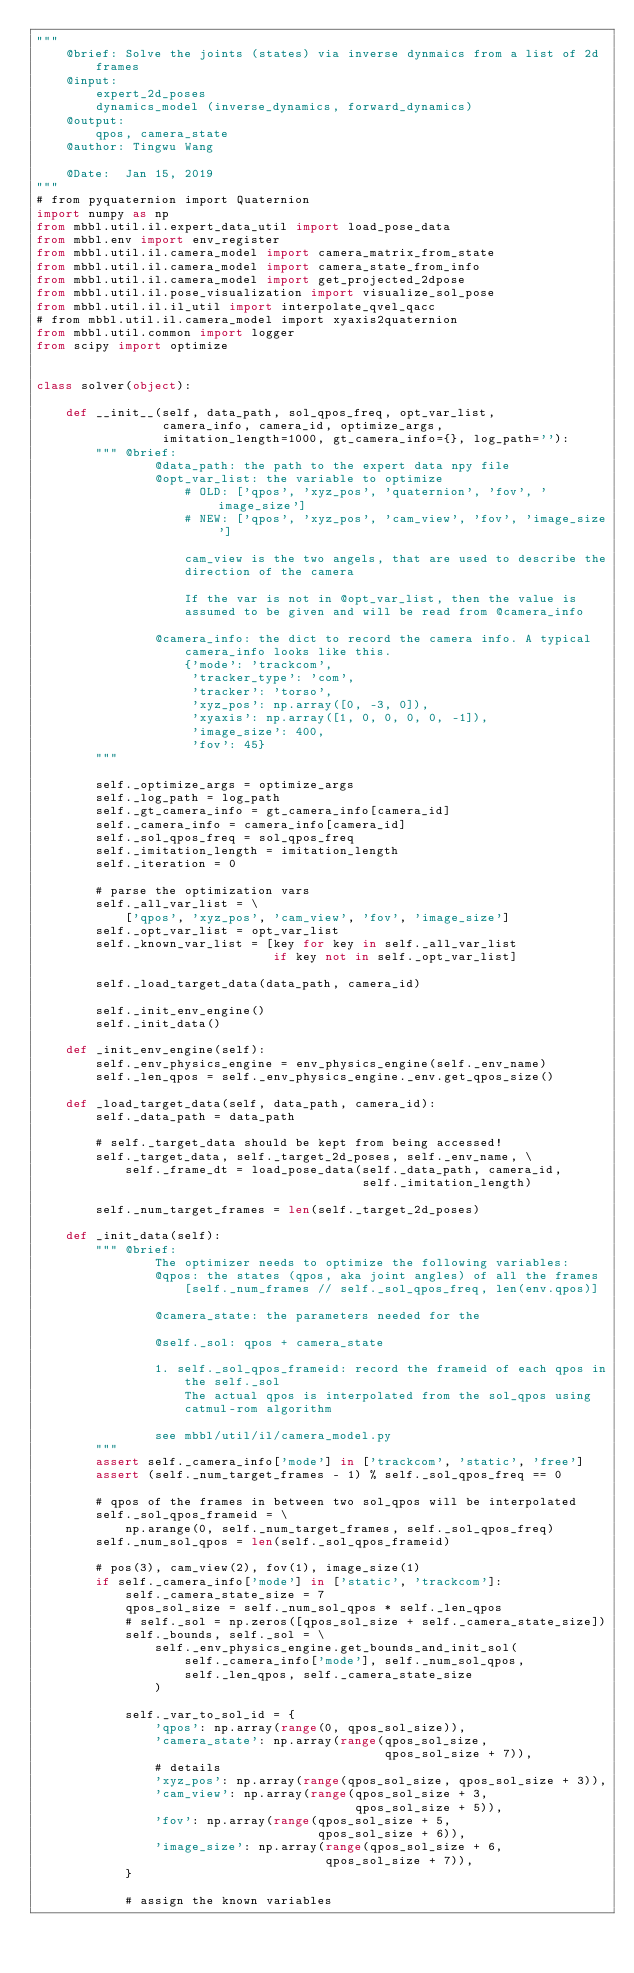<code> <loc_0><loc_0><loc_500><loc_500><_Python_>"""
    @brief: Solve the joints (states) via inverse dynmaics from a list of 2d
        frames
    @input:
        expert_2d_poses
        dynamics_model (inverse_dynamics, forward_dynamics)
    @output:
        qpos, camera_state
    @author: Tingwu Wang

    @Date:  Jan 15, 2019
"""
# from pyquaternion import Quaternion
import numpy as np
from mbbl.util.il.expert_data_util import load_pose_data
from mbbl.env import env_register
from mbbl.util.il.camera_model import camera_matrix_from_state
from mbbl.util.il.camera_model import camera_state_from_info
from mbbl.util.il.camera_model import get_projected_2dpose
from mbbl.util.il.pose_visualization import visualize_sol_pose
from mbbl.util.il.il_util import interpolate_qvel_qacc
# from mbbl.util.il.camera_model import xyaxis2quaternion
from mbbl.util.common import logger
from scipy import optimize


class solver(object):

    def __init__(self, data_path, sol_qpos_freq, opt_var_list,
                 camera_info, camera_id, optimize_args,
                 imitation_length=1000, gt_camera_info={}, log_path=''):
        """ @brief:
                @data_path: the path to the expert data npy file
                @opt_var_list: the variable to optimize
                    # OLD: ['qpos', 'xyz_pos', 'quaternion', 'fov', 'image_size']
                    # NEW: ['qpos', 'xyz_pos', 'cam_view', 'fov', 'image_size']

                    cam_view is the two angels, that are used to describe the
                    direction of the camera

                    If the var is not in @opt_var_list, then the value is
                    assumed to be given and will be read from @camera_info

                @camera_info: the dict to record the camera info. A typical
                    camera_info looks like this.
                    {'mode': 'trackcom',
                     'tracker_type': 'com',
                     'tracker': 'torso',
                     'xyz_pos': np.array([0, -3, 0]),
                     'xyaxis': np.array([1, 0, 0, 0, 0, -1]),
                     'image_size': 400,
                     'fov': 45}
        """

        self._optimize_args = optimize_args
        self._log_path = log_path
        self._gt_camera_info = gt_camera_info[camera_id]
        self._camera_info = camera_info[camera_id]
        self._sol_qpos_freq = sol_qpos_freq
        self._imitation_length = imitation_length
        self._iteration = 0

        # parse the optimization vars
        self._all_var_list = \
            ['qpos', 'xyz_pos', 'cam_view', 'fov', 'image_size']
        self._opt_var_list = opt_var_list
        self._known_var_list = [key for key in self._all_var_list
                                if key not in self._opt_var_list]

        self._load_target_data(data_path, camera_id)

        self._init_env_engine()
        self._init_data()

    def _init_env_engine(self):
        self._env_physics_engine = env_physics_engine(self._env_name)
        self._len_qpos = self._env_physics_engine._env.get_qpos_size()

    def _load_target_data(self, data_path, camera_id):
        self._data_path = data_path

        # self._target_data should be kept from being accessed!
        self._target_data, self._target_2d_poses, self._env_name, \
            self._frame_dt = load_pose_data(self._data_path, camera_id,
                                            self._imitation_length)

        self._num_target_frames = len(self._target_2d_poses)

    def _init_data(self):
        """ @brief:
                The optimizer needs to optimize the following variables:
                @qpos: the states (qpos, aka joint angles) of all the frames
                    [self._num_frames // self._sol_qpos_freq, len(env.qpos)]

                @camera_state: the parameters needed for the

                @self._sol: qpos + camera_state

                1. self._sol_qpos_frameid: record the frameid of each qpos in
                    the self._sol
                    The actual qpos is interpolated from the sol_qpos using
                    catmul-rom algorithm

                see mbbl/util/il/camera_model.py
        """
        assert self._camera_info['mode'] in ['trackcom', 'static', 'free']
        assert (self._num_target_frames - 1) % self._sol_qpos_freq == 0

        # qpos of the frames in between two sol_qpos will be interpolated
        self._sol_qpos_frameid = \
            np.arange(0, self._num_target_frames, self._sol_qpos_freq)
        self._num_sol_qpos = len(self._sol_qpos_frameid)

        # pos(3), cam_view(2), fov(1), image_size(1)
        if self._camera_info['mode'] in ['static', 'trackcom']:
            self._camera_state_size = 7
            qpos_sol_size = self._num_sol_qpos * self._len_qpos
            # self._sol = np.zeros([qpos_sol_size + self._camera_state_size])
            self._bounds, self._sol = \
                self._env_physics_engine.get_bounds_and_init_sol(
                    self._camera_info['mode'], self._num_sol_qpos,
                    self._len_qpos, self._camera_state_size
                )

            self._var_to_sol_id = {
                'qpos': np.array(range(0, qpos_sol_size)),
                'camera_state': np.array(range(qpos_sol_size,
                                               qpos_sol_size + 7)),
                # details
                'xyz_pos': np.array(range(qpos_sol_size, qpos_sol_size + 3)),
                'cam_view': np.array(range(qpos_sol_size + 3,
                                           qpos_sol_size + 5)),
                'fov': np.array(range(qpos_sol_size + 5,
                                      qpos_sol_size + 6)),
                'image_size': np.array(range(qpos_sol_size + 6,
                                       qpos_sol_size + 7)),
            }

            # assign the known variables</code> 